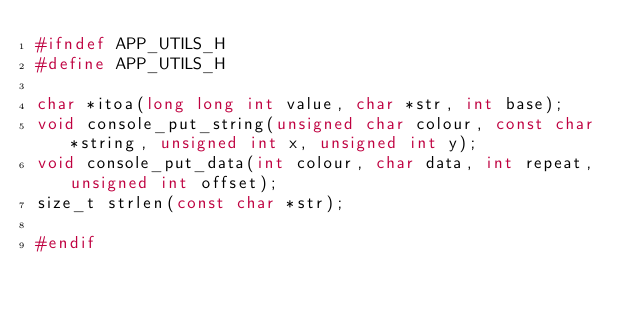<code> <loc_0><loc_0><loc_500><loc_500><_C_>#ifndef APP_UTILS_H
#define	APP_UTILS_H

char *itoa(long long int value, char *str, int base);
void console_put_string(unsigned char colour, const char *string, unsigned int x, unsigned int y);
void console_put_data(int colour, char data, int repeat, unsigned int offset);
size_t strlen(const char *str);

#endif</code> 